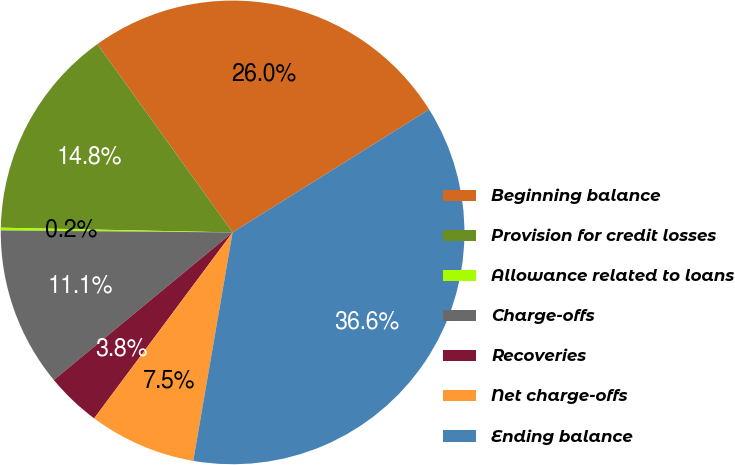Convert chart to OTSL. <chart><loc_0><loc_0><loc_500><loc_500><pie_chart><fcel>Beginning balance<fcel>Provision for credit losses<fcel>Allowance related to loans<fcel>Charge-offs<fcel>Recoveries<fcel>Net charge-offs<fcel>Ending balance<nl><fcel>26.02%<fcel>14.76%<fcel>0.19%<fcel>11.12%<fcel>3.83%<fcel>7.47%<fcel>36.61%<nl></chart> 